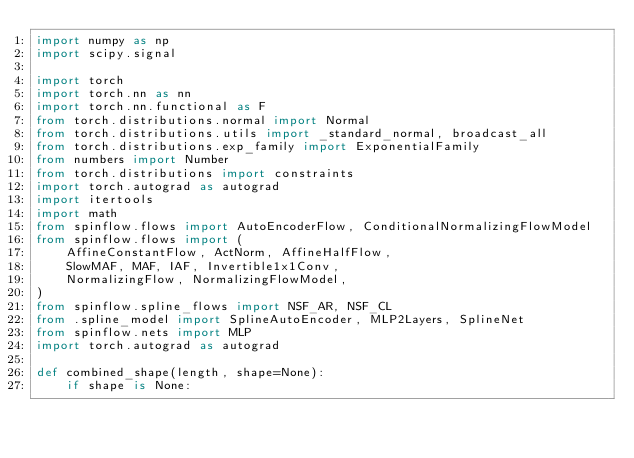Convert code to text. <code><loc_0><loc_0><loc_500><loc_500><_Python_>import numpy as np
import scipy.signal

import torch
import torch.nn as nn
import torch.nn.functional as F
from torch.distributions.normal import Normal
from torch.distributions.utils import _standard_normal, broadcast_all
from torch.distributions.exp_family import ExponentialFamily
from numbers import Number
from torch.distributions import constraints
import torch.autograd as autograd
import itertools
import math
from spinflow.flows import AutoEncoderFlow, ConditionalNormalizingFlowModel
from spinflow.flows import (
    AffineConstantFlow, ActNorm, AffineHalfFlow,
    SlowMAF, MAF, IAF, Invertible1x1Conv,
    NormalizingFlow, NormalizingFlowModel,
)
from spinflow.spline_flows import NSF_AR, NSF_CL
from .spline_model import SplineAutoEncoder, MLP2Layers, SplineNet
from spinflow.nets import MLP
import torch.autograd as autograd

def combined_shape(length, shape=None):
    if shape is None:</code> 